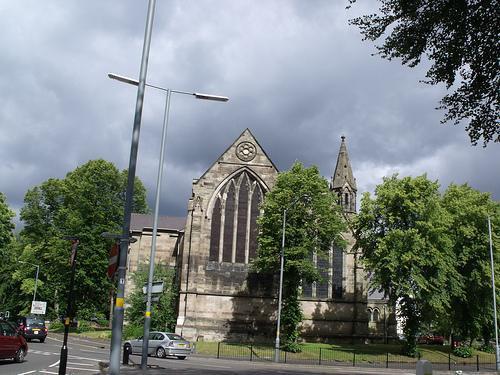How many churches are there?
Give a very brief answer. 1. 